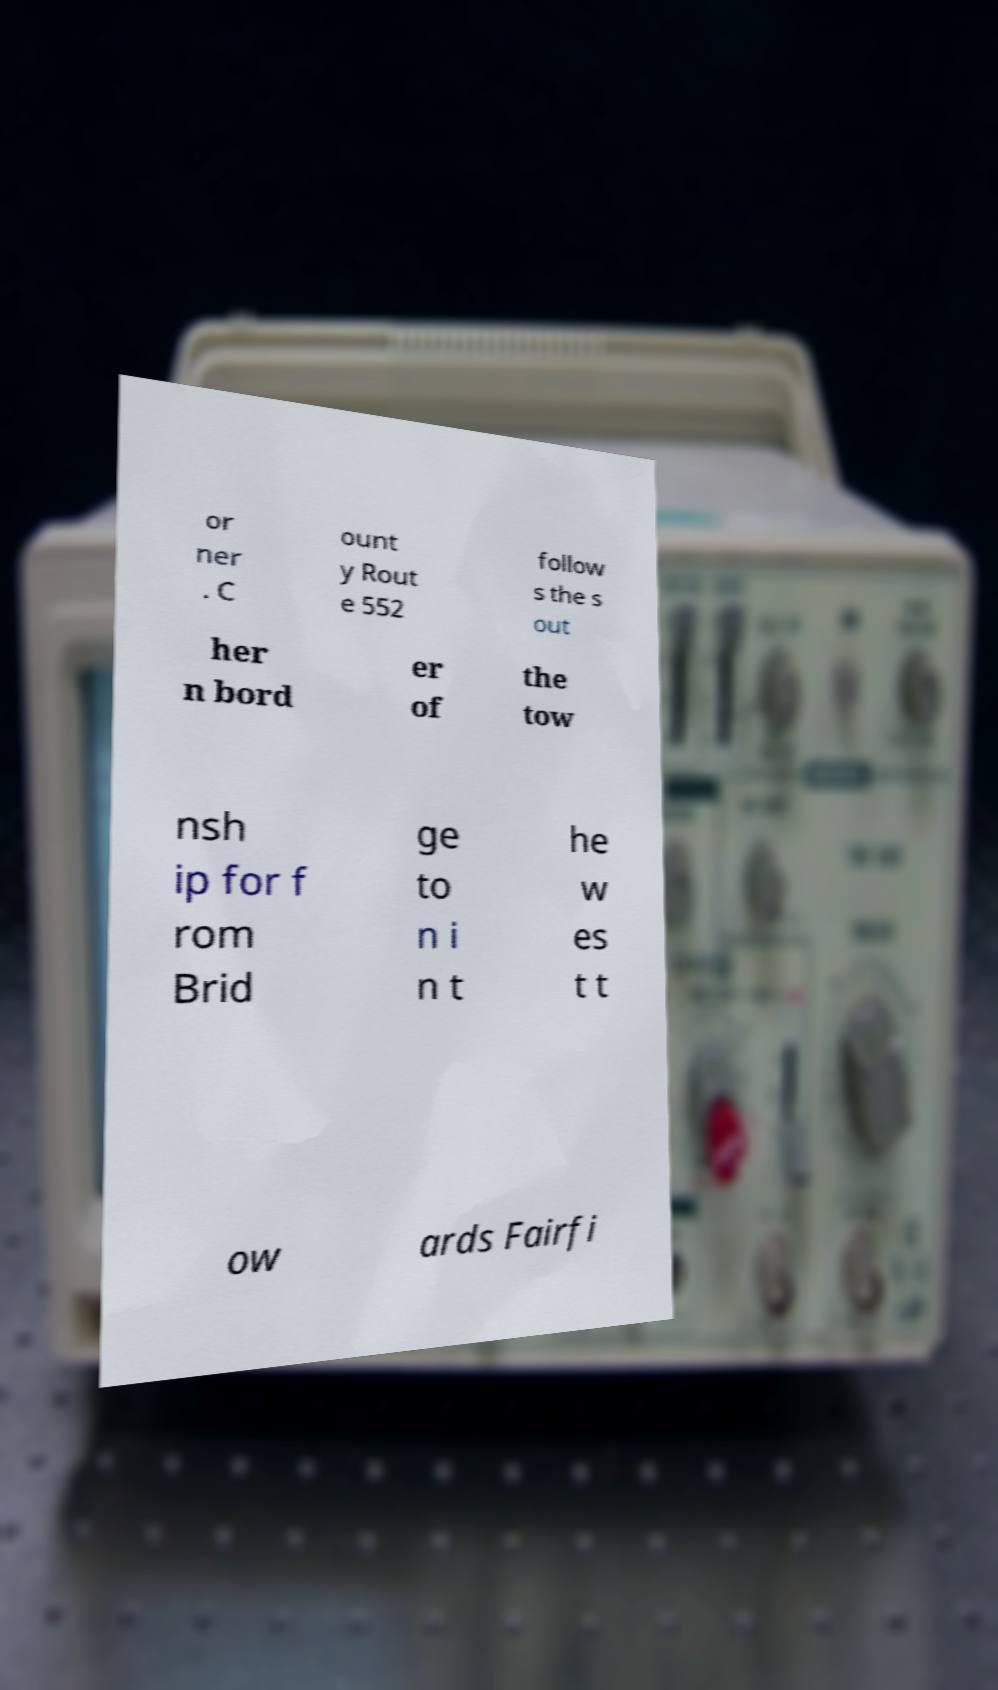Can you read and provide the text displayed in the image?This photo seems to have some interesting text. Can you extract and type it out for me? or ner . C ount y Rout e 552 follow s the s out her n bord er of the tow nsh ip for f rom Brid ge to n i n t he w es t t ow ards Fairfi 